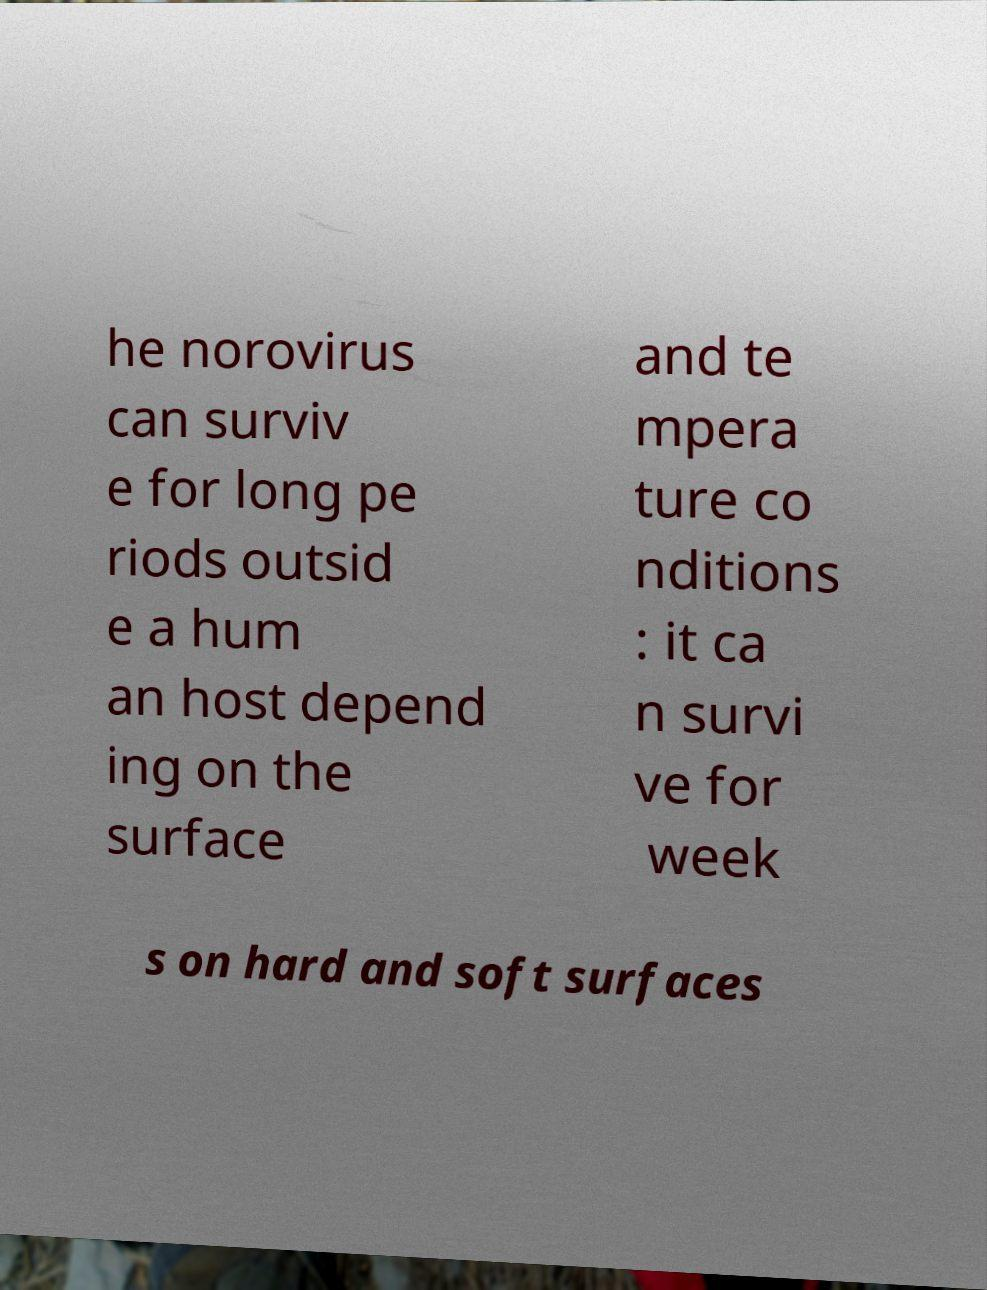Can you read and provide the text displayed in the image?This photo seems to have some interesting text. Can you extract and type it out for me? he norovirus can surviv e for long pe riods outsid e a hum an host depend ing on the surface and te mpera ture co nditions : it ca n survi ve for week s on hard and soft surfaces 